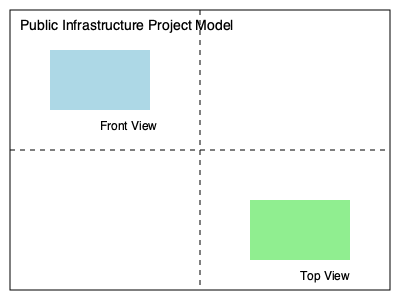As part of a transparency initiative for a new public infrastructure project, you are tasked with matching different views of the project model. Given the front view and top view of a building in the model, which statement is correct about the building's orientation? To determine the correct orientation of the building, we need to analyze the given front and top views:

1. Front View:
   - Located in the upper-left quadrant
   - Represented by a blue rectangle

2. Top View:
   - Located in the lower-right quadrant
   - Represented by a green rectangle

3. Orientation analysis:
   - The front view shows the building's width and height
   - The top view shows the building's width and depth

4. Comparing the views:
   - The width appears the same in both views (similar horizontal dimension)
   - The front view's vertical dimension (height) is different from the top view's vertical dimension (depth)

5. Conclusion:
   - The building is wider than it is tall
   - The building is deeper than it is tall
   - The front of the building faces the upper-left direction in the model

This orientation explains why the front view is in the upper-left quadrant and the top view is in the lower-right quadrant.
Answer: The building's front faces the upper-left direction, and it is wider and deeper than it is tall. 